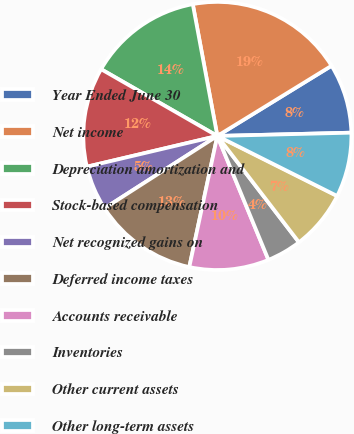Convert chart to OTSL. <chart><loc_0><loc_0><loc_500><loc_500><pie_chart><fcel>Year Ended June 30<fcel>Net income<fcel>Depreciation amortization and<fcel>Stock-based compensation<fcel>Net recognized gains on<fcel>Deferred income taxes<fcel>Accounts receivable<fcel>Inventories<fcel>Other current assets<fcel>Other long-term assets<nl><fcel>8.38%<fcel>19.16%<fcel>13.77%<fcel>11.98%<fcel>5.39%<fcel>12.57%<fcel>9.58%<fcel>4.19%<fcel>7.19%<fcel>7.78%<nl></chart> 